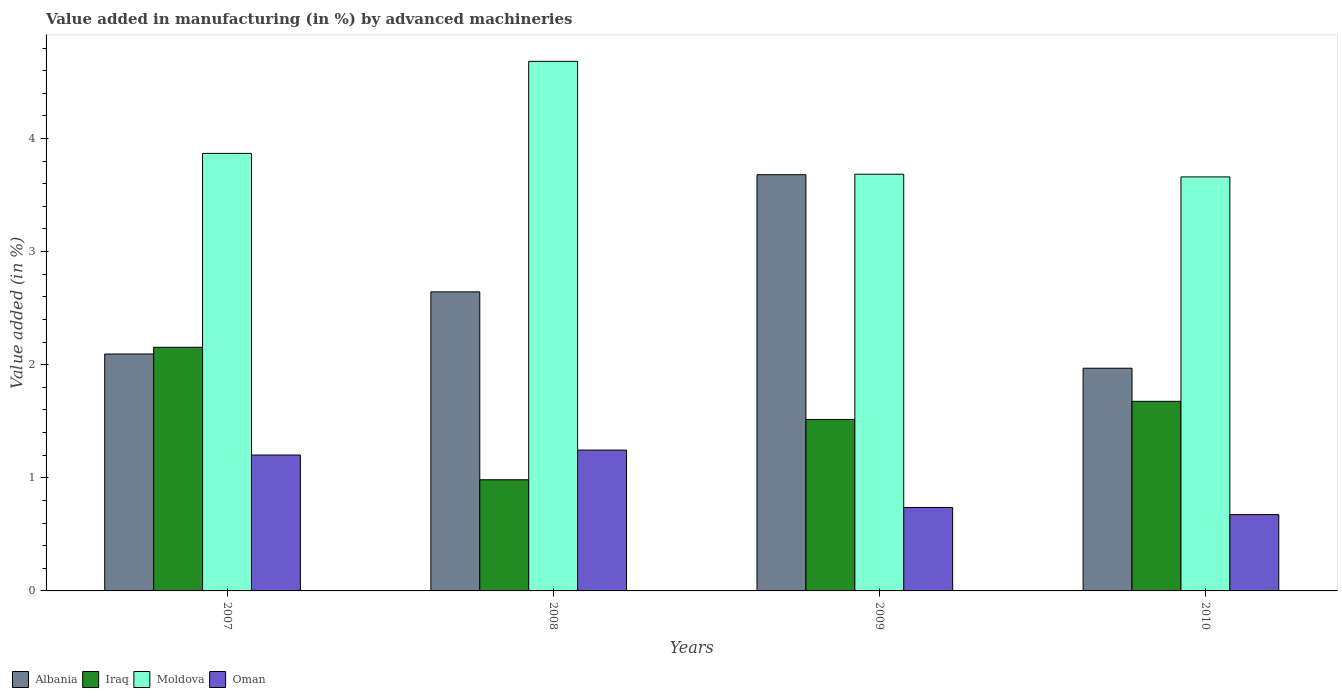How many different coloured bars are there?
Your answer should be very brief. 4. Are the number of bars on each tick of the X-axis equal?
Offer a very short reply. Yes. What is the label of the 4th group of bars from the left?
Your answer should be compact. 2010. What is the percentage of value added in manufacturing by advanced machineries in Albania in 2008?
Offer a very short reply. 2.64. Across all years, what is the maximum percentage of value added in manufacturing by advanced machineries in Albania?
Provide a short and direct response. 3.68. Across all years, what is the minimum percentage of value added in manufacturing by advanced machineries in Oman?
Provide a short and direct response. 0.67. In which year was the percentage of value added in manufacturing by advanced machineries in Iraq minimum?
Your answer should be very brief. 2008. What is the total percentage of value added in manufacturing by advanced machineries in Albania in the graph?
Make the answer very short. 10.39. What is the difference between the percentage of value added in manufacturing by advanced machineries in Iraq in 2008 and that in 2009?
Offer a very short reply. -0.53. What is the difference between the percentage of value added in manufacturing by advanced machineries in Moldova in 2008 and the percentage of value added in manufacturing by advanced machineries in Oman in 2007?
Ensure brevity in your answer.  3.48. What is the average percentage of value added in manufacturing by advanced machineries in Oman per year?
Your answer should be compact. 0.96. In the year 2010, what is the difference between the percentage of value added in manufacturing by advanced machineries in Moldova and percentage of value added in manufacturing by advanced machineries in Oman?
Ensure brevity in your answer.  2.99. In how many years, is the percentage of value added in manufacturing by advanced machineries in Albania greater than 1 %?
Offer a terse response. 4. What is the ratio of the percentage of value added in manufacturing by advanced machineries in Albania in 2007 to that in 2010?
Keep it short and to the point. 1.06. Is the percentage of value added in manufacturing by advanced machineries in Oman in 2007 less than that in 2010?
Provide a short and direct response. No. Is the difference between the percentage of value added in manufacturing by advanced machineries in Moldova in 2008 and 2009 greater than the difference between the percentage of value added in manufacturing by advanced machineries in Oman in 2008 and 2009?
Provide a succinct answer. Yes. What is the difference between the highest and the second highest percentage of value added in manufacturing by advanced machineries in Oman?
Provide a short and direct response. 0.04. What is the difference between the highest and the lowest percentage of value added in manufacturing by advanced machineries in Oman?
Provide a succinct answer. 0.57. Is the sum of the percentage of value added in manufacturing by advanced machineries in Iraq in 2009 and 2010 greater than the maximum percentage of value added in manufacturing by advanced machineries in Albania across all years?
Give a very brief answer. No. Is it the case that in every year, the sum of the percentage of value added in manufacturing by advanced machineries in Iraq and percentage of value added in manufacturing by advanced machineries in Moldova is greater than the sum of percentage of value added in manufacturing by advanced machineries in Oman and percentage of value added in manufacturing by advanced machineries in Albania?
Offer a very short reply. Yes. What does the 3rd bar from the left in 2010 represents?
Give a very brief answer. Moldova. What does the 1st bar from the right in 2008 represents?
Make the answer very short. Oman. Is it the case that in every year, the sum of the percentage of value added in manufacturing by advanced machineries in Albania and percentage of value added in manufacturing by advanced machineries in Iraq is greater than the percentage of value added in manufacturing by advanced machineries in Moldova?
Give a very brief answer. No. How many years are there in the graph?
Keep it short and to the point. 4. What is the difference between two consecutive major ticks on the Y-axis?
Your response must be concise. 1. Does the graph contain grids?
Offer a very short reply. No. Where does the legend appear in the graph?
Your answer should be compact. Bottom left. What is the title of the graph?
Your answer should be compact. Value added in manufacturing (in %) by advanced machineries. What is the label or title of the X-axis?
Offer a very short reply. Years. What is the label or title of the Y-axis?
Your answer should be compact. Value added (in %). What is the Value added (in %) in Albania in 2007?
Provide a succinct answer. 2.09. What is the Value added (in %) in Iraq in 2007?
Offer a very short reply. 2.15. What is the Value added (in %) of Moldova in 2007?
Offer a terse response. 3.87. What is the Value added (in %) in Oman in 2007?
Offer a terse response. 1.2. What is the Value added (in %) in Albania in 2008?
Your answer should be compact. 2.64. What is the Value added (in %) in Iraq in 2008?
Provide a short and direct response. 0.98. What is the Value added (in %) in Moldova in 2008?
Provide a short and direct response. 4.68. What is the Value added (in %) in Oman in 2008?
Ensure brevity in your answer.  1.25. What is the Value added (in %) of Albania in 2009?
Give a very brief answer. 3.68. What is the Value added (in %) of Iraq in 2009?
Offer a terse response. 1.52. What is the Value added (in %) in Moldova in 2009?
Provide a short and direct response. 3.68. What is the Value added (in %) of Oman in 2009?
Your response must be concise. 0.74. What is the Value added (in %) in Albania in 2010?
Offer a terse response. 1.97. What is the Value added (in %) in Iraq in 2010?
Provide a succinct answer. 1.68. What is the Value added (in %) of Moldova in 2010?
Offer a very short reply. 3.66. What is the Value added (in %) of Oman in 2010?
Your response must be concise. 0.67. Across all years, what is the maximum Value added (in %) in Albania?
Your answer should be compact. 3.68. Across all years, what is the maximum Value added (in %) in Iraq?
Your answer should be compact. 2.15. Across all years, what is the maximum Value added (in %) of Moldova?
Your answer should be compact. 4.68. Across all years, what is the maximum Value added (in %) of Oman?
Make the answer very short. 1.25. Across all years, what is the minimum Value added (in %) of Albania?
Your answer should be very brief. 1.97. Across all years, what is the minimum Value added (in %) in Iraq?
Your answer should be very brief. 0.98. Across all years, what is the minimum Value added (in %) of Moldova?
Your answer should be very brief. 3.66. Across all years, what is the minimum Value added (in %) in Oman?
Your answer should be very brief. 0.67. What is the total Value added (in %) in Albania in the graph?
Your answer should be very brief. 10.39. What is the total Value added (in %) of Iraq in the graph?
Offer a very short reply. 6.33. What is the total Value added (in %) in Moldova in the graph?
Your answer should be very brief. 15.9. What is the total Value added (in %) in Oman in the graph?
Keep it short and to the point. 3.86. What is the difference between the Value added (in %) in Albania in 2007 and that in 2008?
Keep it short and to the point. -0.55. What is the difference between the Value added (in %) in Iraq in 2007 and that in 2008?
Your response must be concise. 1.17. What is the difference between the Value added (in %) in Moldova in 2007 and that in 2008?
Your answer should be compact. -0.81. What is the difference between the Value added (in %) of Oman in 2007 and that in 2008?
Your response must be concise. -0.04. What is the difference between the Value added (in %) in Albania in 2007 and that in 2009?
Offer a terse response. -1.59. What is the difference between the Value added (in %) in Iraq in 2007 and that in 2009?
Your answer should be compact. 0.64. What is the difference between the Value added (in %) in Moldova in 2007 and that in 2009?
Ensure brevity in your answer.  0.18. What is the difference between the Value added (in %) of Oman in 2007 and that in 2009?
Your answer should be compact. 0.46. What is the difference between the Value added (in %) in Albania in 2007 and that in 2010?
Your response must be concise. 0.13. What is the difference between the Value added (in %) of Iraq in 2007 and that in 2010?
Your answer should be very brief. 0.48. What is the difference between the Value added (in %) of Moldova in 2007 and that in 2010?
Keep it short and to the point. 0.21. What is the difference between the Value added (in %) of Oman in 2007 and that in 2010?
Your answer should be compact. 0.53. What is the difference between the Value added (in %) of Albania in 2008 and that in 2009?
Provide a short and direct response. -1.04. What is the difference between the Value added (in %) in Iraq in 2008 and that in 2009?
Your answer should be compact. -0.53. What is the difference between the Value added (in %) in Oman in 2008 and that in 2009?
Ensure brevity in your answer.  0.51. What is the difference between the Value added (in %) in Albania in 2008 and that in 2010?
Your answer should be very brief. 0.68. What is the difference between the Value added (in %) in Iraq in 2008 and that in 2010?
Your answer should be compact. -0.69. What is the difference between the Value added (in %) of Moldova in 2008 and that in 2010?
Your response must be concise. 1.02. What is the difference between the Value added (in %) in Oman in 2008 and that in 2010?
Make the answer very short. 0.57. What is the difference between the Value added (in %) of Albania in 2009 and that in 2010?
Your answer should be compact. 1.71. What is the difference between the Value added (in %) in Iraq in 2009 and that in 2010?
Your answer should be compact. -0.16. What is the difference between the Value added (in %) of Moldova in 2009 and that in 2010?
Your answer should be very brief. 0.02. What is the difference between the Value added (in %) in Oman in 2009 and that in 2010?
Keep it short and to the point. 0.06. What is the difference between the Value added (in %) in Albania in 2007 and the Value added (in %) in Iraq in 2008?
Provide a short and direct response. 1.11. What is the difference between the Value added (in %) in Albania in 2007 and the Value added (in %) in Moldova in 2008?
Give a very brief answer. -2.59. What is the difference between the Value added (in %) of Albania in 2007 and the Value added (in %) of Oman in 2008?
Ensure brevity in your answer.  0.85. What is the difference between the Value added (in %) in Iraq in 2007 and the Value added (in %) in Moldova in 2008?
Make the answer very short. -2.53. What is the difference between the Value added (in %) of Iraq in 2007 and the Value added (in %) of Oman in 2008?
Keep it short and to the point. 0.91. What is the difference between the Value added (in %) in Moldova in 2007 and the Value added (in %) in Oman in 2008?
Your answer should be compact. 2.62. What is the difference between the Value added (in %) of Albania in 2007 and the Value added (in %) of Iraq in 2009?
Offer a terse response. 0.58. What is the difference between the Value added (in %) in Albania in 2007 and the Value added (in %) in Moldova in 2009?
Your answer should be very brief. -1.59. What is the difference between the Value added (in %) of Albania in 2007 and the Value added (in %) of Oman in 2009?
Give a very brief answer. 1.36. What is the difference between the Value added (in %) in Iraq in 2007 and the Value added (in %) in Moldova in 2009?
Provide a short and direct response. -1.53. What is the difference between the Value added (in %) of Iraq in 2007 and the Value added (in %) of Oman in 2009?
Provide a short and direct response. 1.42. What is the difference between the Value added (in %) of Moldova in 2007 and the Value added (in %) of Oman in 2009?
Ensure brevity in your answer.  3.13. What is the difference between the Value added (in %) of Albania in 2007 and the Value added (in %) of Iraq in 2010?
Make the answer very short. 0.42. What is the difference between the Value added (in %) of Albania in 2007 and the Value added (in %) of Moldova in 2010?
Give a very brief answer. -1.57. What is the difference between the Value added (in %) in Albania in 2007 and the Value added (in %) in Oman in 2010?
Keep it short and to the point. 1.42. What is the difference between the Value added (in %) in Iraq in 2007 and the Value added (in %) in Moldova in 2010?
Your answer should be compact. -1.51. What is the difference between the Value added (in %) in Iraq in 2007 and the Value added (in %) in Oman in 2010?
Make the answer very short. 1.48. What is the difference between the Value added (in %) in Moldova in 2007 and the Value added (in %) in Oman in 2010?
Offer a very short reply. 3.19. What is the difference between the Value added (in %) in Albania in 2008 and the Value added (in %) in Iraq in 2009?
Give a very brief answer. 1.13. What is the difference between the Value added (in %) in Albania in 2008 and the Value added (in %) in Moldova in 2009?
Provide a succinct answer. -1.04. What is the difference between the Value added (in %) of Albania in 2008 and the Value added (in %) of Oman in 2009?
Provide a short and direct response. 1.91. What is the difference between the Value added (in %) of Iraq in 2008 and the Value added (in %) of Moldova in 2009?
Your answer should be very brief. -2.7. What is the difference between the Value added (in %) in Iraq in 2008 and the Value added (in %) in Oman in 2009?
Offer a very short reply. 0.24. What is the difference between the Value added (in %) of Moldova in 2008 and the Value added (in %) of Oman in 2009?
Keep it short and to the point. 3.94. What is the difference between the Value added (in %) in Albania in 2008 and the Value added (in %) in Moldova in 2010?
Make the answer very short. -1.02. What is the difference between the Value added (in %) in Albania in 2008 and the Value added (in %) in Oman in 2010?
Your response must be concise. 1.97. What is the difference between the Value added (in %) in Iraq in 2008 and the Value added (in %) in Moldova in 2010?
Provide a succinct answer. -2.68. What is the difference between the Value added (in %) of Iraq in 2008 and the Value added (in %) of Oman in 2010?
Offer a very short reply. 0.31. What is the difference between the Value added (in %) of Moldova in 2008 and the Value added (in %) of Oman in 2010?
Your answer should be compact. 4.01. What is the difference between the Value added (in %) in Albania in 2009 and the Value added (in %) in Iraq in 2010?
Your answer should be compact. 2. What is the difference between the Value added (in %) in Albania in 2009 and the Value added (in %) in Moldova in 2010?
Your response must be concise. 0.02. What is the difference between the Value added (in %) of Albania in 2009 and the Value added (in %) of Oman in 2010?
Keep it short and to the point. 3.01. What is the difference between the Value added (in %) of Iraq in 2009 and the Value added (in %) of Moldova in 2010?
Offer a very short reply. -2.14. What is the difference between the Value added (in %) of Iraq in 2009 and the Value added (in %) of Oman in 2010?
Offer a terse response. 0.84. What is the difference between the Value added (in %) in Moldova in 2009 and the Value added (in %) in Oman in 2010?
Provide a succinct answer. 3.01. What is the average Value added (in %) in Albania per year?
Ensure brevity in your answer.  2.6. What is the average Value added (in %) in Iraq per year?
Make the answer very short. 1.58. What is the average Value added (in %) in Moldova per year?
Your response must be concise. 3.97. What is the average Value added (in %) in Oman per year?
Offer a terse response. 0.96. In the year 2007, what is the difference between the Value added (in %) of Albania and Value added (in %) of Iraq?
Your answer should be compact. -0.06. In the year 2007, what is the difference between the Value added (in %) in Albania and Value added (in %) in Moldova?
Give a very brief answer. -1.77. In the year 2007, what is the difference between the Value added (in %) in Albania and Value added (in %) in Oman?
Offer a very short reply. 0.89. In the year 2007, what is the difference between the Value added (in %) of Iraq and Value added (in %) of Moldova?
Provide a short and direct response. -1.71. In the year 2007, what is the difference between the Value added (in %) in Iraq and Value added (in %) in Oman?
Make the answer very short. 0.95. In the year 2007, what is the difference between the Value added (in %) in Moldova and Value added (in %) in Oman?
Keep it short and to the point. 2.67. In the year 2008, what is the difference between the Value added (in %) in Albania and Value added (in %) in Iraq?
Provide a succinct answer. 1.66. In the year 2008, what is the difference between the Value added (in %) in Albania and Value added (in %) in Moldova?
Keep it short and to the point. -2.04. In the year 2008, what is the difference between the Value added (in %) in Albania and Value added (in %) in Oman?
Provide a short and direct response. 1.4. In the year 2008, what is the difference between the Value added (in %) of Iraq and Value added (in %) of Moldova?
Keep it short and to the point. -3.7. In the year 2008, what is the difference between the Value added (in %) of Iraq and Value added (in %) of Oman?
Your answer should be compact. -0.26. In the year 2008, what is the difference between the Value added (in %) of Moldova and Value added (in %) of Oman?
Provide a succinct answer. 3.44. In the year 2009, what is the difference between the Value added (in %) in Albania and Value added (in %) in Iraq?
Offer a very short reply. 2.16. In the year 2009, what is the difference between the Value added (in %) of Albania and Value added (in %) of Moldova?
Offer a terse response. -0. In the year 2009, what is the difference between the Value added (in %) of Albania and Value added (in %) of Oman?
Offer a terse response. 2.94. In the year 2009, what is the difference between the Value added (in %) of Iraq and Value added (in %) of Moldova?
Ensure brevity in your answer.  -2.17. In the year 2009, what is the difference between the Value added (in %) in Iraq and Value added (in %) in Oman?
Give a very brief answer. 0.78. In the year 2009, what is the difference between the Value added (in %) in Moldova and Value added (in %) in Oman?
Provide a short and direct response. 2.95. In the year 2010, what is the difference between the Value added (in %) in Albania and Value added (in %) in Iraq?
Your answer should be compact. 0.29. In the year 2010, what is the difference between the Value added (in %) in Albania and Value added (in %) in Moldova?
Keep it short and to the point. -1.69. In the year 2010, what is the difference between the Value added (in %) in Albania and Value added (in %) in Oman?
Provide a short and direct response. 1.29. In the year 2010, what is the difference between the Value added (in %) of Iraq and Value added (in %) of Moldova?
Provide a short and direct response. -1.98. In the year 2010, what is the difference between the Value added (in %) in Iraq and Value added (in %) in Oman?
Make the answer very short. 1. In the year 2010, what is the difference between the Value added (in %) in Moldova and Value added (in %) in Oman?
Give a very brief answer. 2.99. What is the ratio of the Value added (in %) of Albania in 2007 to that in 2008?
Offer a very short reply. 0.79. What is the ratio of the Value added (in %) in Iraq in 2007 to that in 2008?
Make the answer very short. 2.19. What is the ratio of the Value added (in %) in Moldova in 2007 to that in 2008?
Your answer should be very brief. 0.83. What is the ratio of the Value added (in %) in Oman in 2007 to that in 2008?
Ensure brevity in your answer.  0.96. What is the ratio of the Value added (in %) of Albania in 2007 to that in 2009?
Offer a terse response. 0.57. What is the ratio of the Value added (in %) of Iraq in 2007 to that in 2009?
Give a very brief answer. 1.42. What is the ratio of the Value added (in %) in Oman in 2007 to that in 2009?
Provide a short and direct response. 1.63. What is the ratio of the Value added (in %) of Albania in 2007 to that in 2010?
Give a very brief answer. 1.06. What is the ratio of the Value added (in %) in Iraq in 2007 to that in 2010?
Ensure brevity in your answer.  1.28. What is the ratio of the Value added (in %) of Moldova in 2007 to that in 2010?
Make the answer very short. 1.06. What is the ratio of the Value added (in %) in Oman in 2007 to that in 2010?
Your answer should be compact. 1.78. What is the ratio of the Value added (in %) of Albania in 2008 to that in 2009?
Keep it short and to the point. 0.72. What is the ratio of the Value added (in %) of Iraq in 2008 to that in 2009?
Ensure brevity in your answer.  0.65. What is the ratio of the Value added (in %) in Moldova in 2008 to that in 2009?
Offer a terse response. 1.27. What is the ratio of the Value added (in %) of Oman in 2008 to that in 2009?
Make the answer very short. 1.69. What is the ratio of the Value added (in %) in Albania in 2008 to that in 2010?
Your response must be concise. 1.34. What is the ratio of the Value added (in %) of Iraq in 2008 to that in 2010?
Your response must be concise. 0.59. What is the ratio of the Value added (in %) of Moldova in 2008 to that in 2010?
Keep it short and to the point. 1.28. What is the ratio of the Value added (in %) of Oman in 2008 to that in 2010?
Your answer should be very brief. 1.85. What is the ratio of the Value added (in %) of Albania in 2009 to that in 2010?
Your answer should be compact. 1.87. What is the ratio of the Value added (in %) in Iraq in 2009 to that in 2010?
Give a very brief answer. 0.9. What is the ratio of the Value added (in %) of Moldova in 2009 to that in 2010?
Your answer should be very brief. 1.01. What is the ratio of the Value added (in %) in Oman in 2009 to that in 2010?
Your response must be concise. 1.09. What is the difference between the highest and the second highest Value added (in %) of Albania?
Offer a very short reply. 1.04. What is the difference between the highest and the second highest Value added (in %) of Iraq?
Give a very brief answer. 0.48. What is the difference between the highest and the second highest Value added (in %) in Moldova?
Give a very brief answer. 0.81. What is the difference between the highest and the second highest Value added (in %) in Oman?
Provide a succinct answer. 0.04. What is the difference between the highest and the lowest Value added (in %) of Albania?
Offer a very short reply. 1.71. What is the difference between the highest and the lowest Value added (in %) of Iraq?
Provide a short and direct response. 1.17. What is the difference between the highest and the lowest Value added (in %) of Moldova?
Offer a very short reply. 1.02. What is the difference between the highest and the lowest Value added (in %) in Oman?
Make the answer very short. 0.57. 